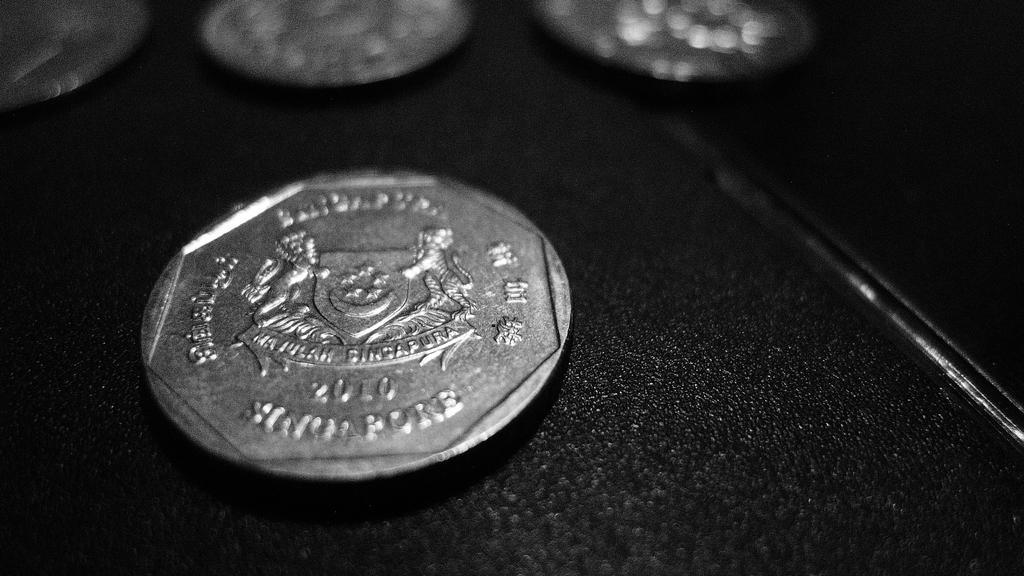Describe this image in one or two sentences. On this black surface we can see coins. This is carved coin. 